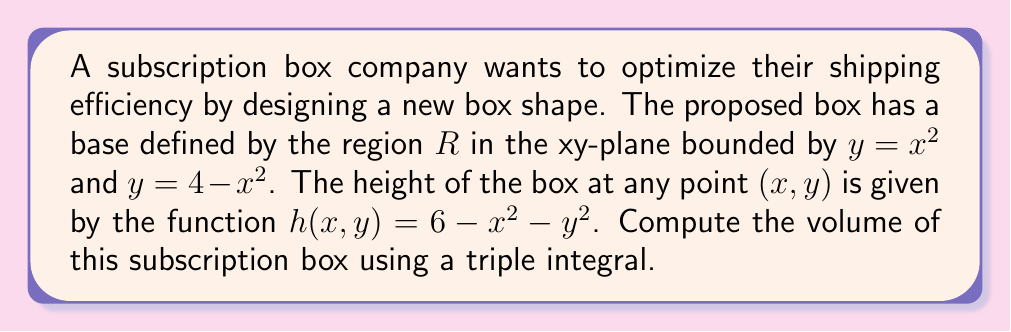What is the answer to this math problem? To solve this problem, we'll use a triple integral to calculate the volume of the subscription box. Let's break it down step-by-step:

1) First, we need to determine the limits of integration for x and y:

   From $y = x^2$ and $y = 4 - x^2$, we can find the x-limits:
   $x^2 = 4 - x^2$
   $2x^2 = 4$
   $x^2 = 2$
   $x = \pm\sqrt{2}$

   So, $x$ ranges from $-\sqrt{2}$ to $\sqrt{2}$.

2) For y, the lower bound is $y = x^2$ and the upper bound is $y = 4 - x^2$.

3) The z-coordinate (height) ranges from 0 to $h(x, y) = 6 - x^2 - y^2$.

4) Now we can set up our triple integral:

   $$V = \int_{-\sqrt{2}}^{\sqrt{2}} \int_{x^2}^{4-x^2} \int_0^{6-x^2-y^2} dz dy dx$$

5) Let's evaluate the innermost integral first:

   $$V = \int_{-\sqrt{2}}^{\sqrt{2}} \int_{x^2}^{4-x^2} [z]_0^{6-x^2-y^2} dy dx$$
   $$V = \int_{-\sqrt{2}}^{\sqrt{2}} \int_{x^2}^{4-x^2} (6-x^2-y^2) dy dx$$

6) Now, let's evaluate the y integral:

   $$V = \int_{-\sqrt{2}}^{\sqrt{2}} \left[6y - x^2y - \frac{1}{3}y^3\right]_{x^2}^{4-x^2} dx$$
   $$V = \int_{-\sqrt{2}}^{\sqrt{2}} \left[(24-6x^2-4x^2+x^4-\frac{64}{3}+\frac{16x^2}{3}-\frac{4x^4}{3}) - (6x^2-x^4-\frac{x^6}{3})\right] dx$$
   $$V = \int_{-\sqrt{2}}^{\sqrt{2}} (24 - 10x^2 + 2x^4 - \frac{64}{3} + \frac{16x^2}{3} - \frac{4x^4}{3} + \frac{x^6}{3}) dx$$

7) Finally, let's evaluate the x integral:

   $$V = \left[24x - \frac{10x^3}{3} + \frac{2x^5}{5} - \frac{64x}{3} + \frac{16x^3}{9} - \frac{4x^5}{15} + \frac{x^7}{21}\right]_{-\sqrt{2}}^{\sqrt{2}}$$

8) Substituting the limits and simplifying:

   $$V = 2\left(24\sqrt{2} - \frac{20\sqrt{2}}{3} + \frac{4\sqrt{2}}{5} - \frac{64\sqrt{2}}{3} + \frac{32\sqrt{2}}{9} - \frac{8\sqrt{2}}{15} + \frac{2\sqrt{2}}{21}\right)$$

9) Simplifying further:

   $$V = \frac{128\sqrt{2}}{15} \approx 12.08$$
Answer: The volume of the subscription box is $\frac{128\sqrt{2}}{15}$ cubic units, or approximately 12.08 cubic units. 